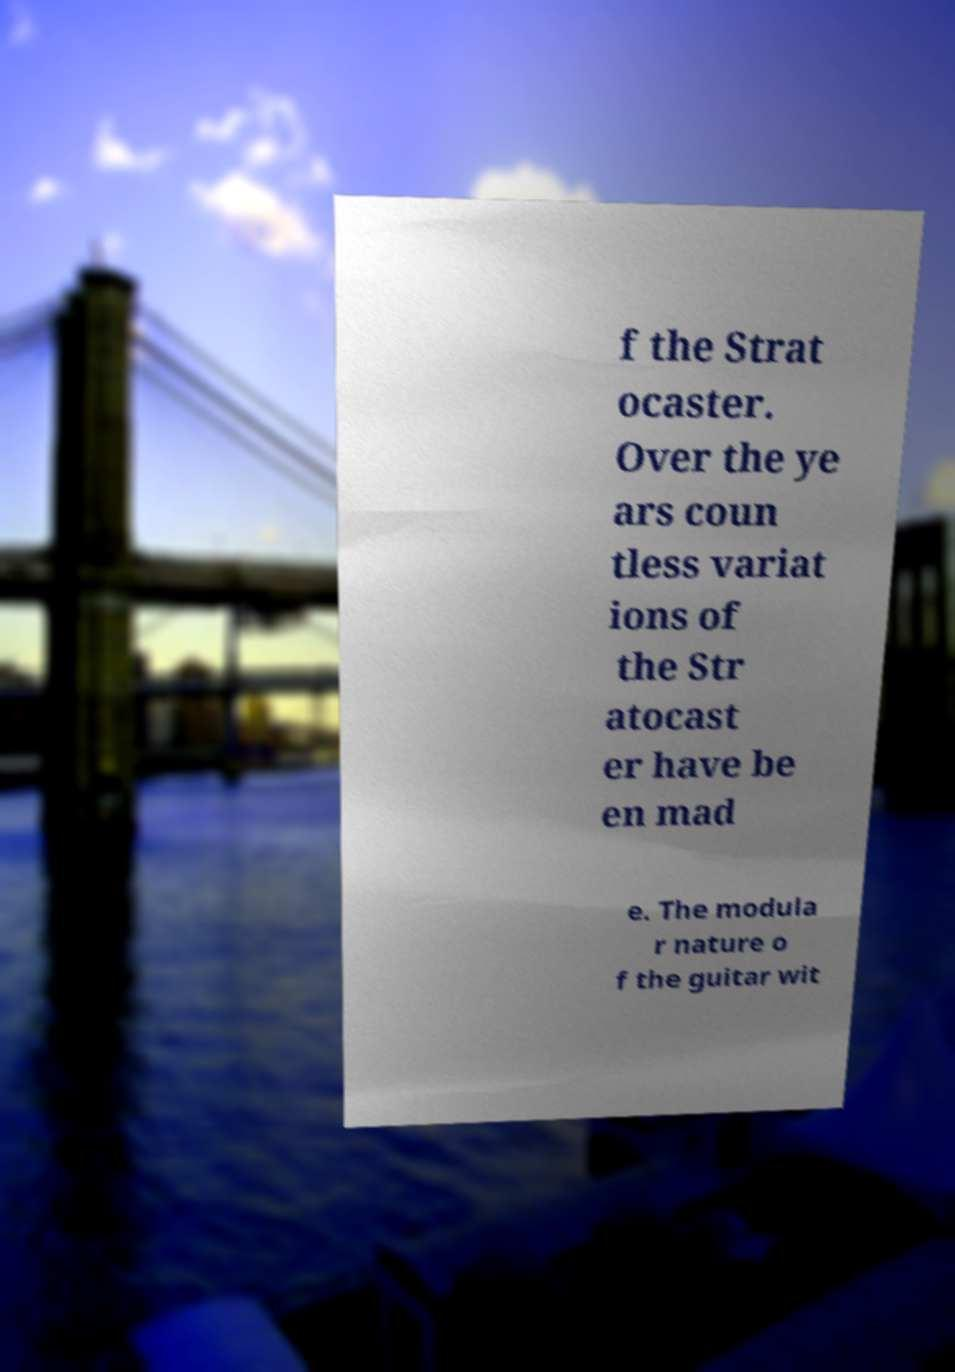Could you assist in decoding the text presented in this image and type it out clearly? f the Strat ocaster. Over the ye ars coun tless variat ions of the Str atocast er have be en mad e. The modula r nature o f the guitar wit 